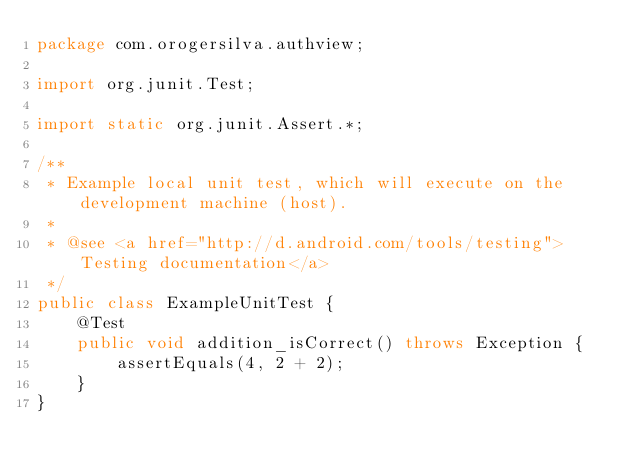Convert code to text. <code><loc_0><loc_0><loc_500><loc_500><_Java_>package com.orogersilva.authview;

import org.junit.Test;

import static org.junit.Assert.*;

/**
 * Example local unit test, which will execute on the development machine (host).
 *
 * @see <a href="http://d.android.com/tools/testing">Testing documentation</a>
 */
public class ExampleUnitTest {
    @Test
    public void addition_isCorrect() throws Exception {
        assertEquals(4, 2 + 2);
    }
}</code> 